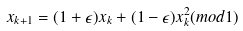Convert formula to latex. <formula><loc_0><loc_0><loc_500><loc_500>x _ { k + 1 } = ( 1 + \epsilon ) x _ { k } + ( 1 - \epsilon ) x _ { k } ^ { 2 } ( m o d 1 )</formula> 